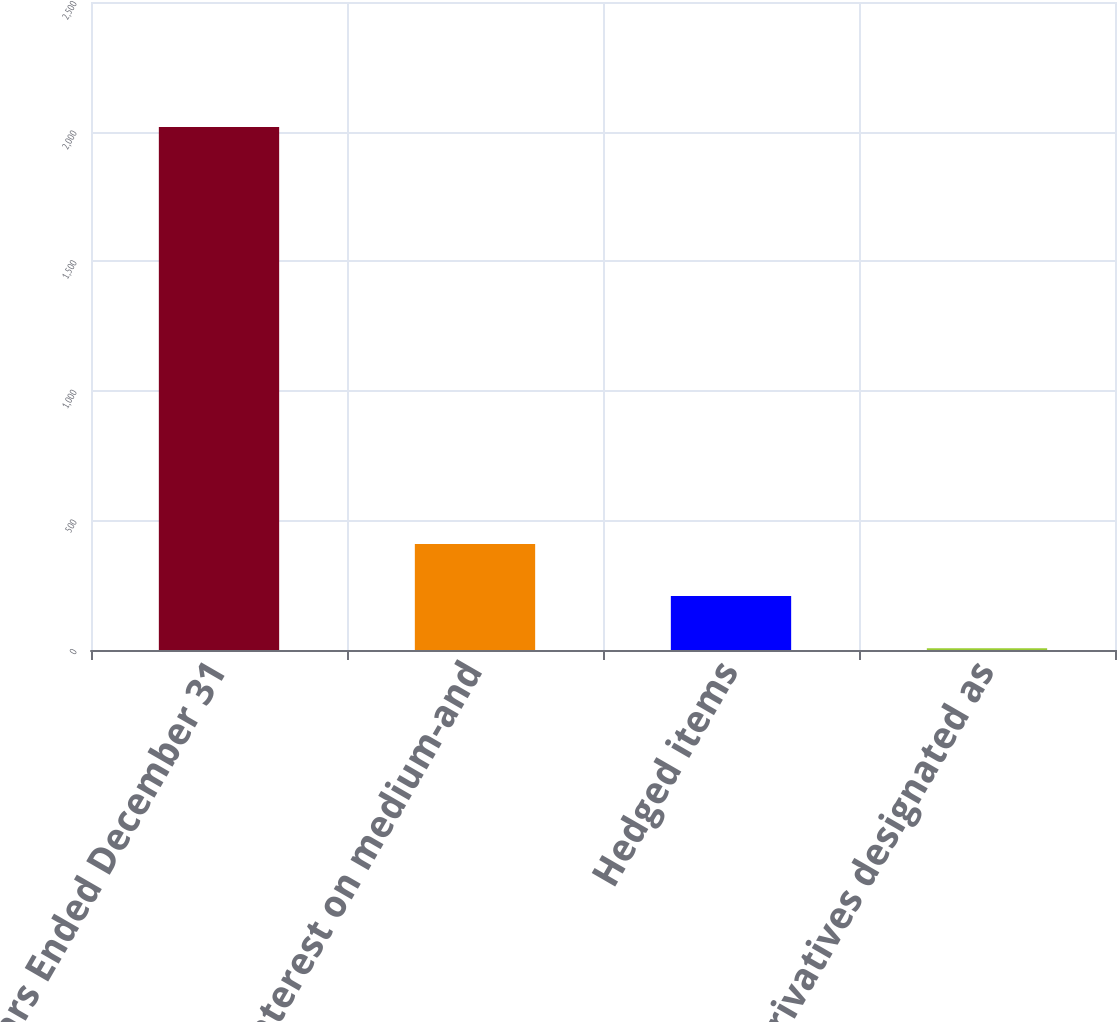Convert chart to OTSL. <chart><loc_0><loc_0><loc_500><loc_500><bar_chart><fcel>Years Ended December 31<fcel>Total interest on medium-and<fcel>Hedged items<fcel>Derivatives designated as<nl><fcel>2018<fcel>409.2<fcel>208.1<fcel>7<nl></chart> 